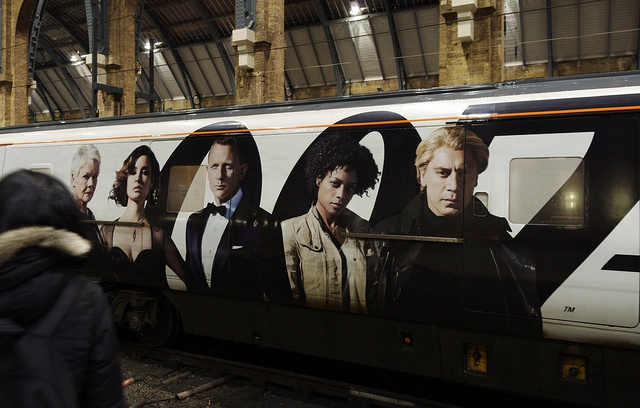Describe the objects in this image and their specific colors. I can see train in black, darkgreen, darkgray, lightgray, and gray tones, people in darkgreen, black, darkgray, and tan tones, people in darkgreen, black, and gray tones, people in darkgreen, black, gray, and darkgray tones, and people in darkgreen, black, darkgray, gray, and maroon tones in this image. 